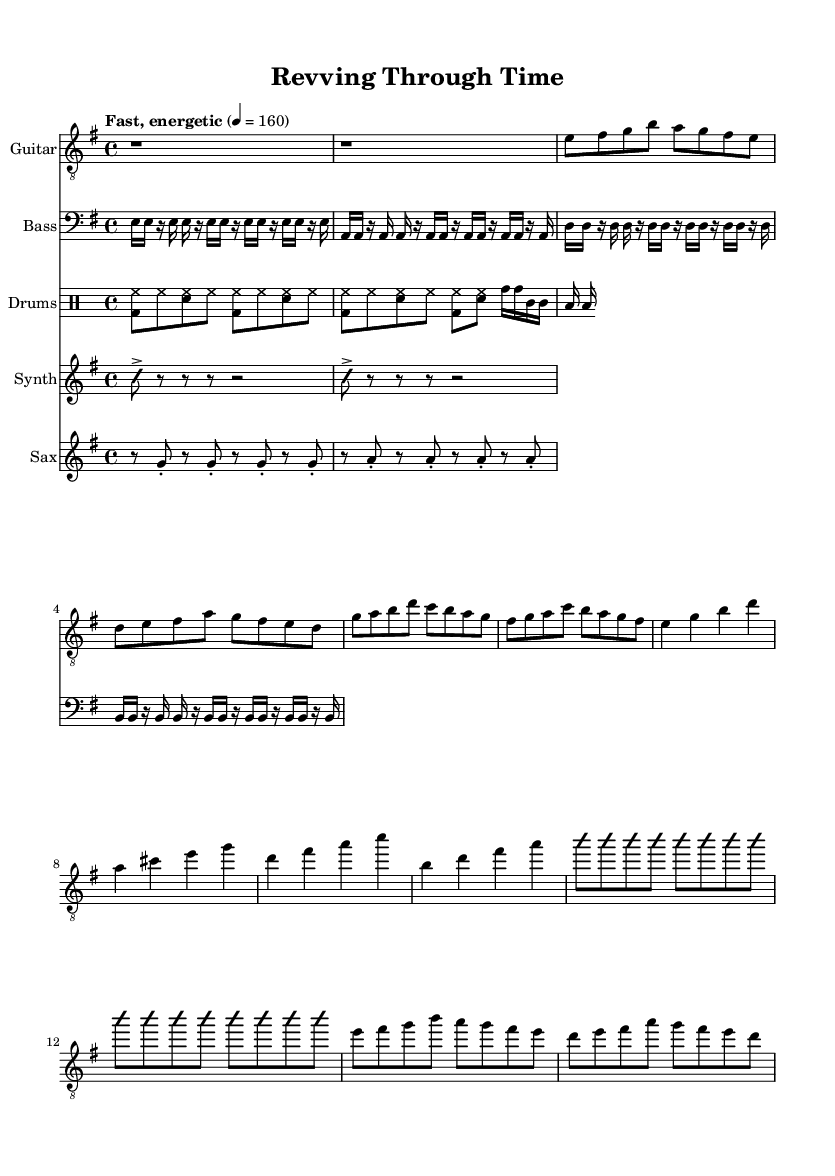What is the key signature of this music? The key signature is indicated by the sharp signs on the staff. In this case, there are two sharps (F# and C#), which corresponds to E minor.
Answer: E minor What is the time signature of this music? The time signature is displayed at the beginning of the staff as a fraction. Here, it shows 4 over 4, meaning there are four beats in each measure.
Answer: 4/4 What is the tempo marking of the piece? The tempo marking is written above the staff as "Fast, energetic 4 = 160", indicating a fast-paced piece with a metronomic mark of 160 beats per minute.
Answer: Fast, energetic How many measures are in the Intro? The Intro section contains two measures, which can be counted from the notation at the beginning of the guitar music.
Answer: 2 What kind of rhythmic pattern does the bass section utilize? The bass section employs a syncopated 16th note pattern, as indicated by the rhythmic notation with alternating notes and rests.
Answer: Syncopated What unique musical characteristic does the synth part mimic? The synth part is designed to mimic engine revs, which is reflected by its repeated notes and rests that create a sense of rising and falling dynamics.
Answer: Engine revs What is the overall style of the music? The overall style is indicated by the combination of jazz and rock elements, including the improvisational nature of the guitar solo and the energetic drum beats, characteristic of jazz-rock fusion.
Answer: Jazz-rock fusion 